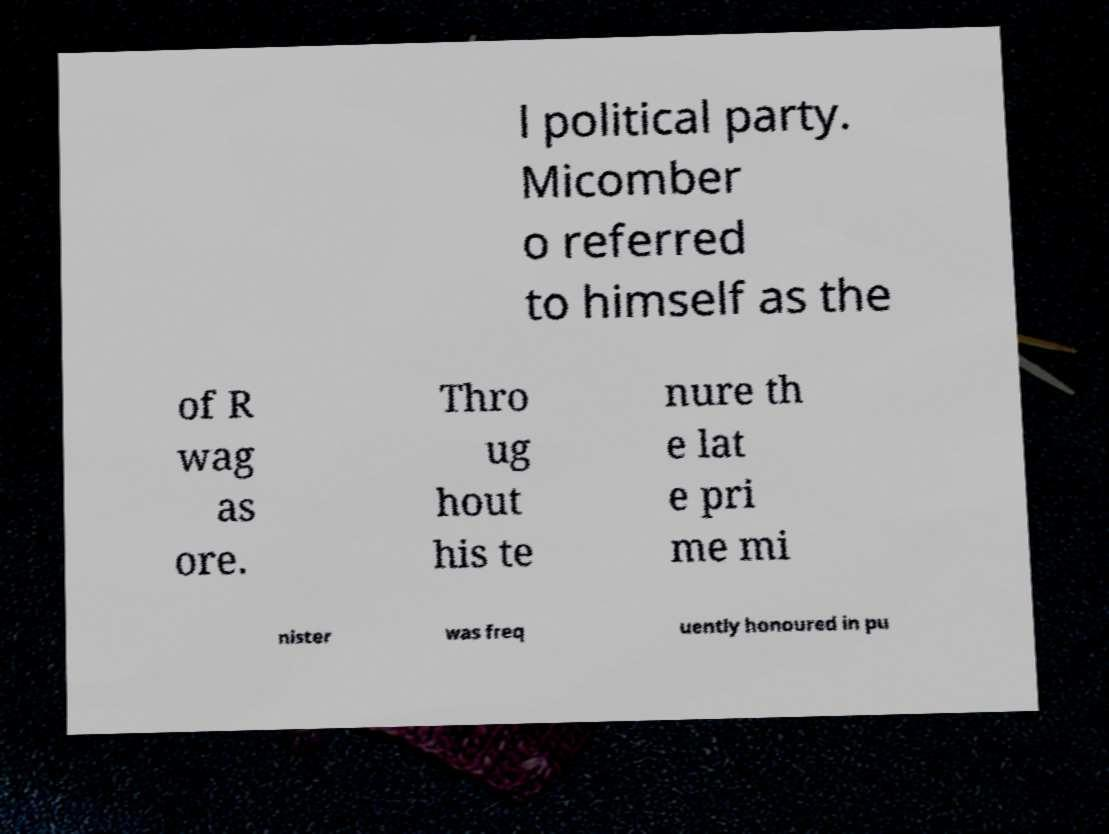For documentation purposes, I need the text within this image transcribed. Could you provide that? l political party. Micomber o referred to himself as the of R wag as ore. Thro ug hout his te nure th e lat e pri me mi nister was freq uently honoured in pu 